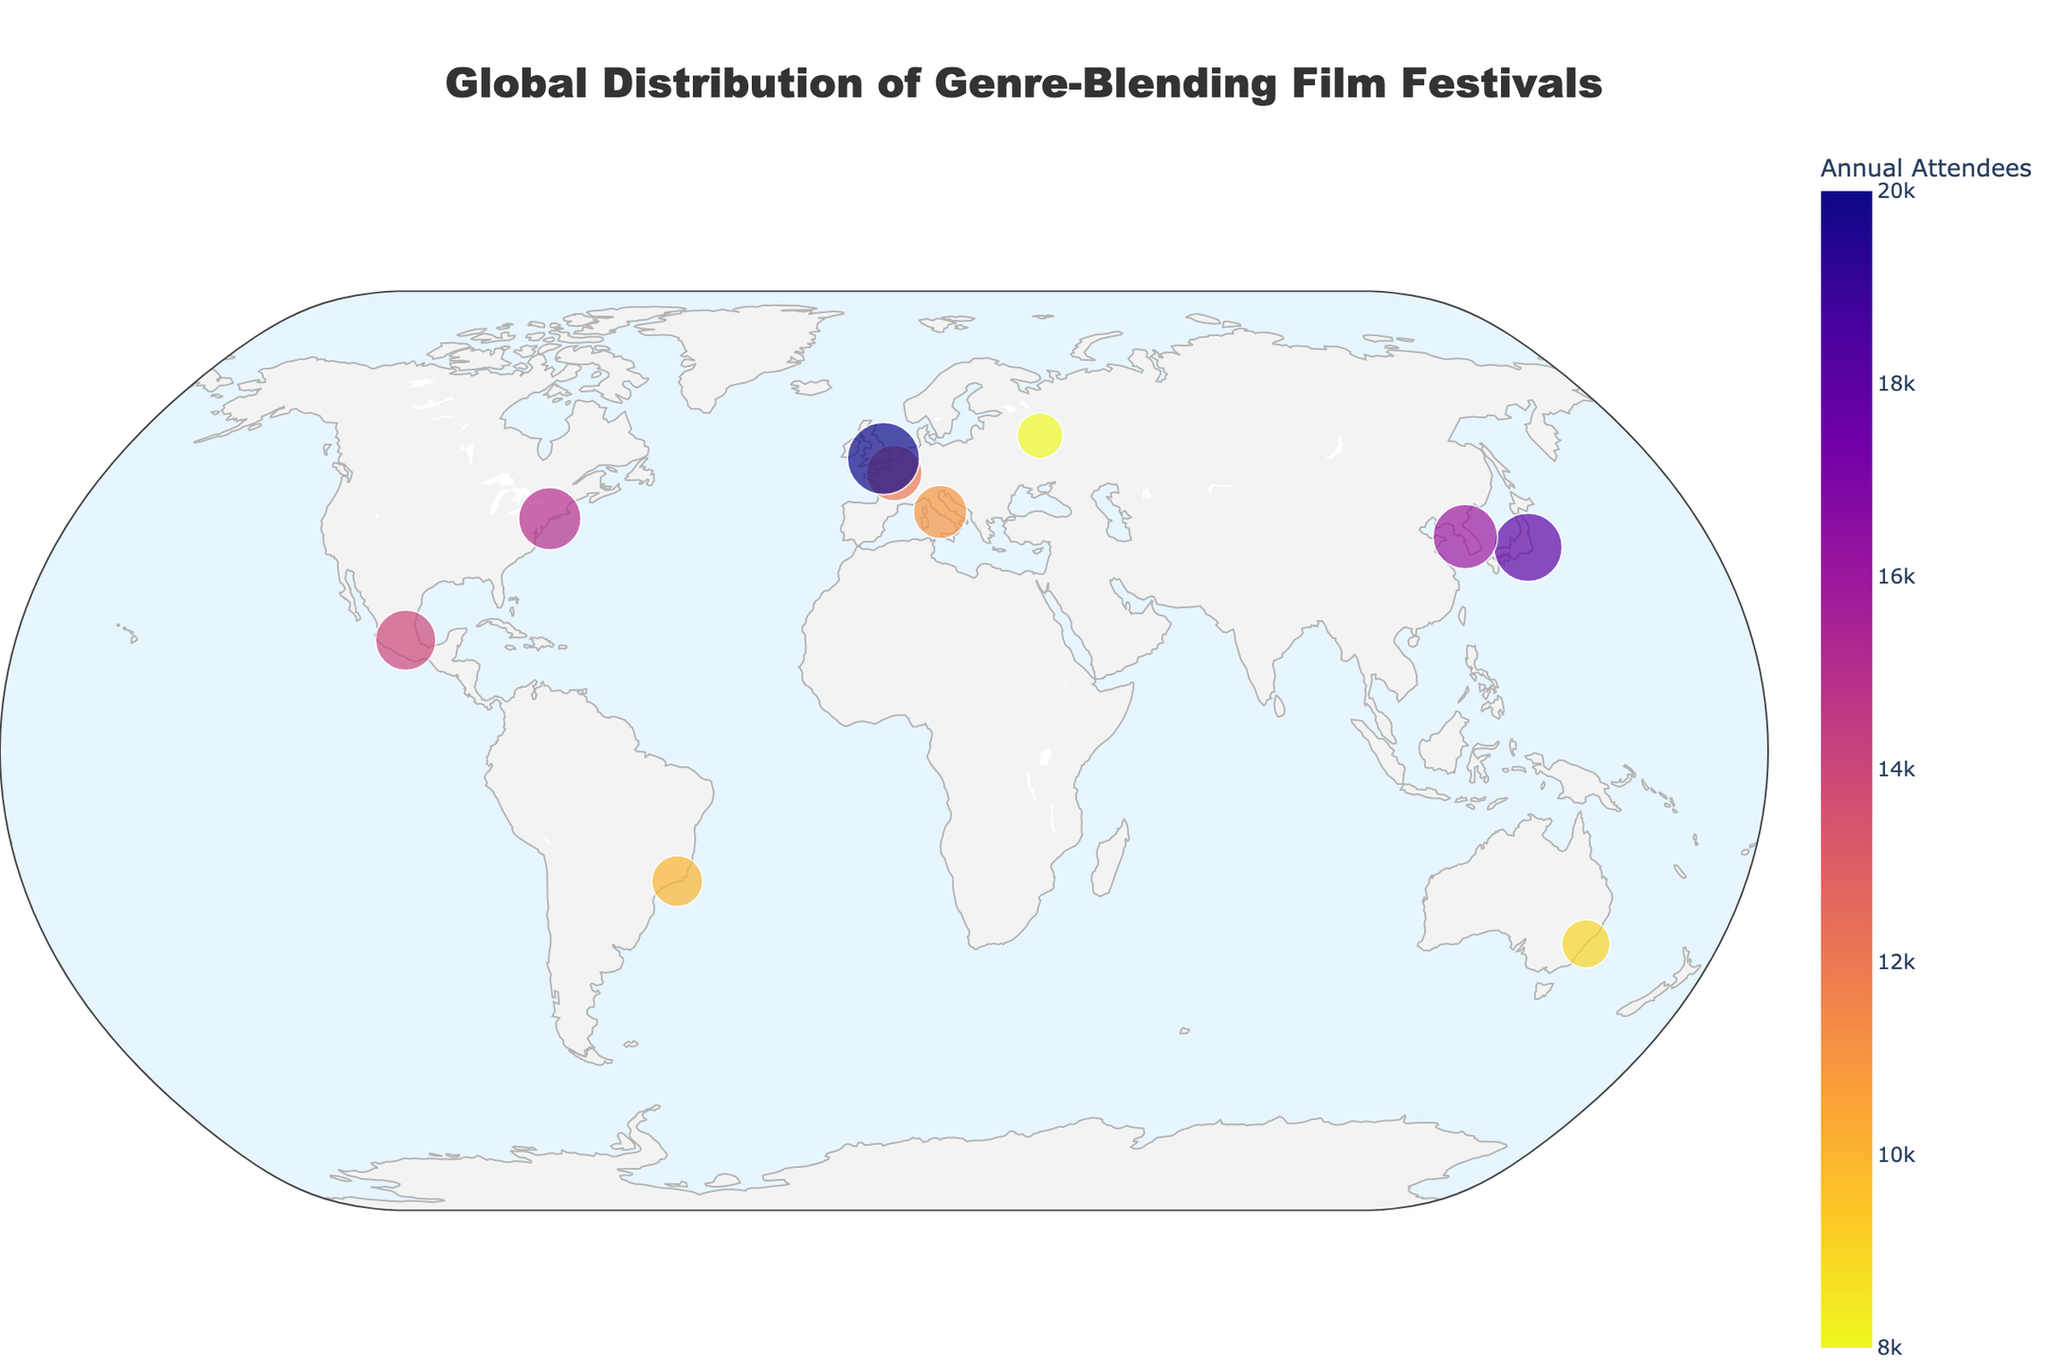what is the festival with the highest annual attendees? Look at the size of the data points and the hover data in the plot; the largest circle corresponds to the London Eclectic Cinema Showcase with 20,000 attendees.
Answer: London Eclectic Cinema Showcase How many festivals feature a blend of Sci-Fi/Western genres? Look for data points with hover text showing 'Sci-Fi/Western' in their "Genre-Blending Focus" attribute; there is only one such entry: New York Fusion Film Festival.
Answer: 1 Which continents host genre-blending film festivals according to the map? Identify the continents based on the geographic locations shown on the map: North America (New York, Mexico City), Europe (Paris, London, Rome, Moscow), Asia (Tokyo, Seoul), Australia (Sydney), and South America (Rio de Janeiro).
Answer: North America, Europe, Asia, Australia, South America Compare the annual attendees for Tokyo Hybrid Visions and Paris Cinematic Crossroads. Which one has more attendees? Check the hover data for both festivals: Tokyo Hybrid Visions has 18,000 attendees, and Paris Cinematic Crossroads has 12,000 attendees.
Answer: Tokyo Hybrid Visions What is the average number of annual attendees for the film festivals in the figure? Sum the annual attendees for all festivals: 15000 + 12000 + 18000 + 9000 + 20000 + 11000 + 14000 + 8000 + 10000 + 16000 = 133000. Divide the sum by the number of festivals (10) to get the average: 133000/10 = 13300.
Answer: 13300 Which festival focuses on a blend of Historical and Dystopian genres? Check the hover data in the plot for "Genre-Blending Focus" to see which festival matches: Moscow Cross-Genre Film Forum.
Answer: Moscow Cross-Genre Film Forum What are the latitudinal extremes of the film festivals shown on the map? Identify the data points with the highest and lowest latitudes: the highest is Moscow (55.7558) and the lowest is Sydney (-33.8688).
Answer: 55.7558 (Moscow), -33.8688 (Sydney) What visual characteristics are used to indicate the number of annual attendees for each film festival? Examine the legend and data points in the plot: larger circles represent higher annual attendee numbers, and color intensity also varies with the number of annual attendees.
Answer: Circle size and color intensity Which city hosts a festival focused on a blend of Comedy and Thriller genres? Look at the hover data for "Genre-Blending Focus" to determine which city matches: Sydney hosts the Genre Mash-Up focused on Comedy/Thriller.
Answer: Sydney 